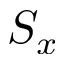<formula> <loc_0><loc_0><loc_500><loc_500>S _ { x }</formula> 